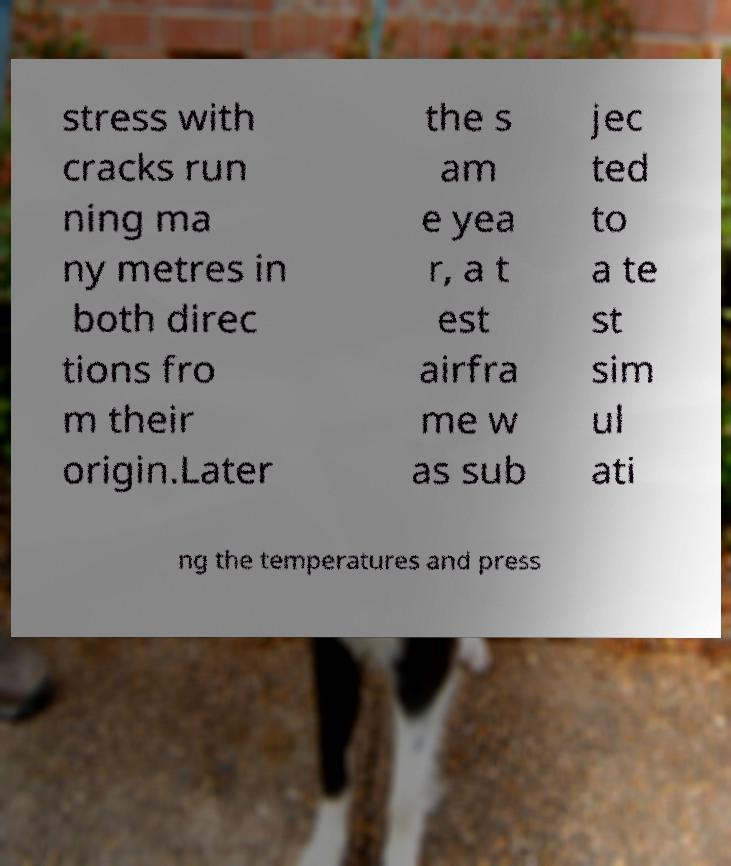What messages or text are displayed in this image? I need them in a readable, typed format. stress with cracks run ning ma ny metres in both direc tions fro m their origin.Later the s am e yea r, a t est airfra me w as sub jec ted to a te st sim ul ati ng the temperatures and press 